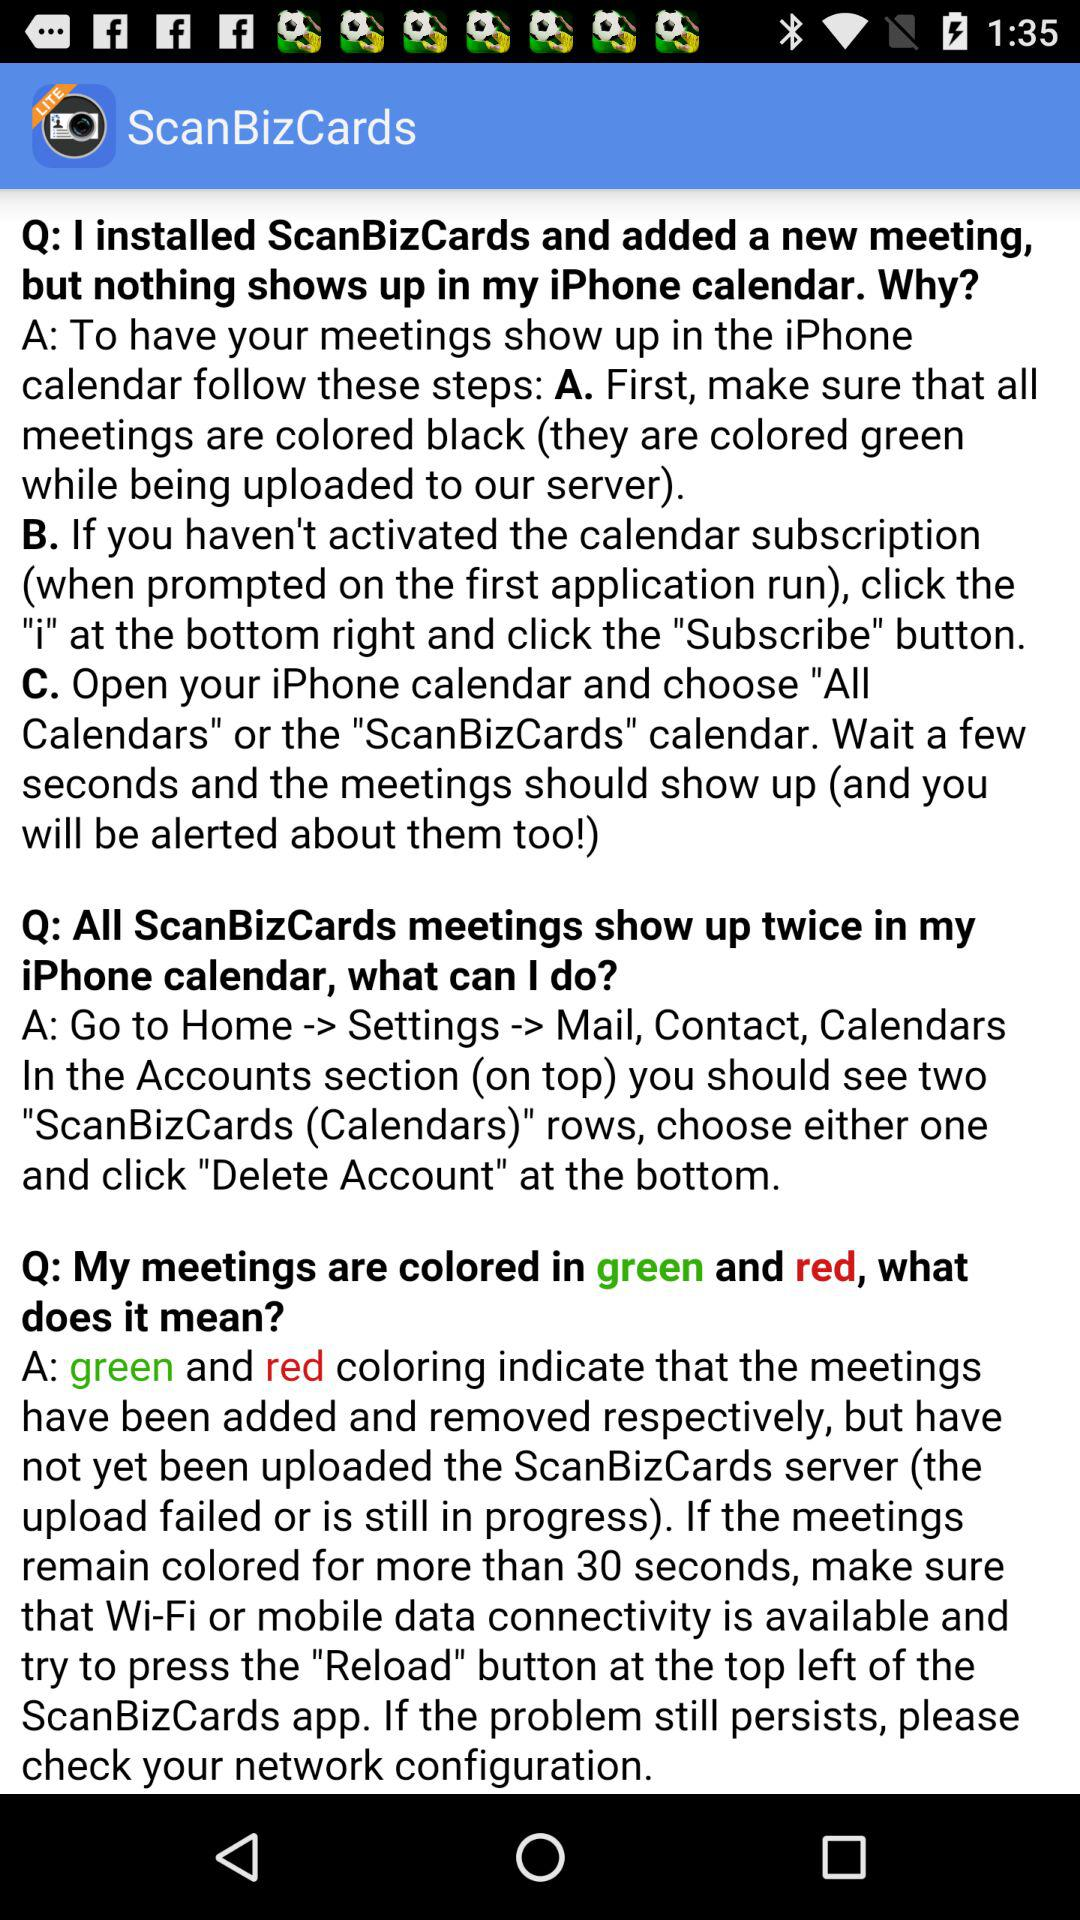How many text blocks are there on this screen?
Answer the question using a single word or phrase. 3 